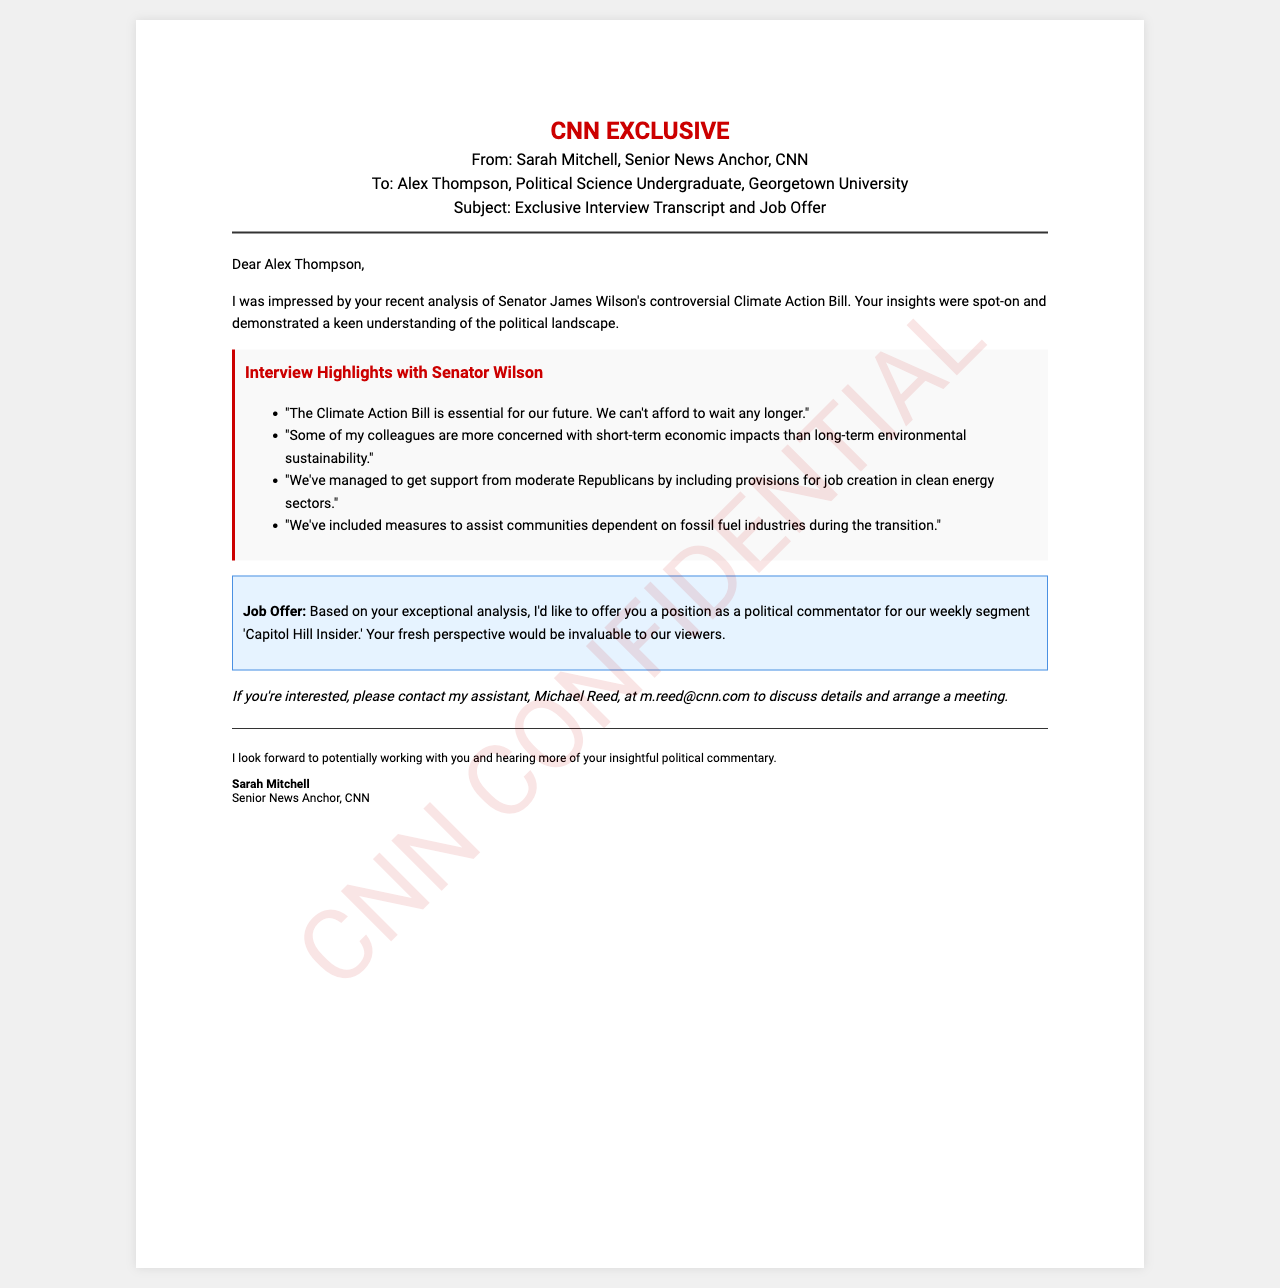What is the subject of the fax? The subject indicates the main topic discussed in the fax, which focuses on the exclusive interview transcript and a job offer.
Answer: Exclusive Interview Transcript and Job Offer Who is the politician interviewed? This question seeks to identify the high-profile figure discussed in the interview highlights.
Answer: Senator James Wilson What does Senator Wilson believe is essential for the future? This asks for a specific belief expressed by the senator regarding the urgency of the legislation.
Answer: The Climate Action Bill What is the position offered to Alex Thompson? This question pertains to the job title mentioned in the job offer section of the fax.
Answer: Political commentator Which segment will Alex Thompson be part of? This seeks the name of the weekly segment mentioned in the job offer where the commentator will contribute.
Answer: Capitol Hill Insider What is the email address for Michael Reed? This question requires the specific contact information provided for the assistant.
Answer: m.reed@cnn.com What are some concerns expressed by Senator Wilson's colleagues? This question looks for issues mentioned related to other senators' priorities regarding the legislation.
Answer: Short-term economic impacts What measures are included in the Climate Action Bill for communities? This asks for specific protective measures included in the legislation to support certain communities.
Answer: Assist communities dependent on fossil fuel industries How does Senator Wilson propose to gain support from moderate Republicans? This probes into the strategy outlined by the senator to gain bipartisan support.
Answer: Including provisions for job creation in clean energy sectors 